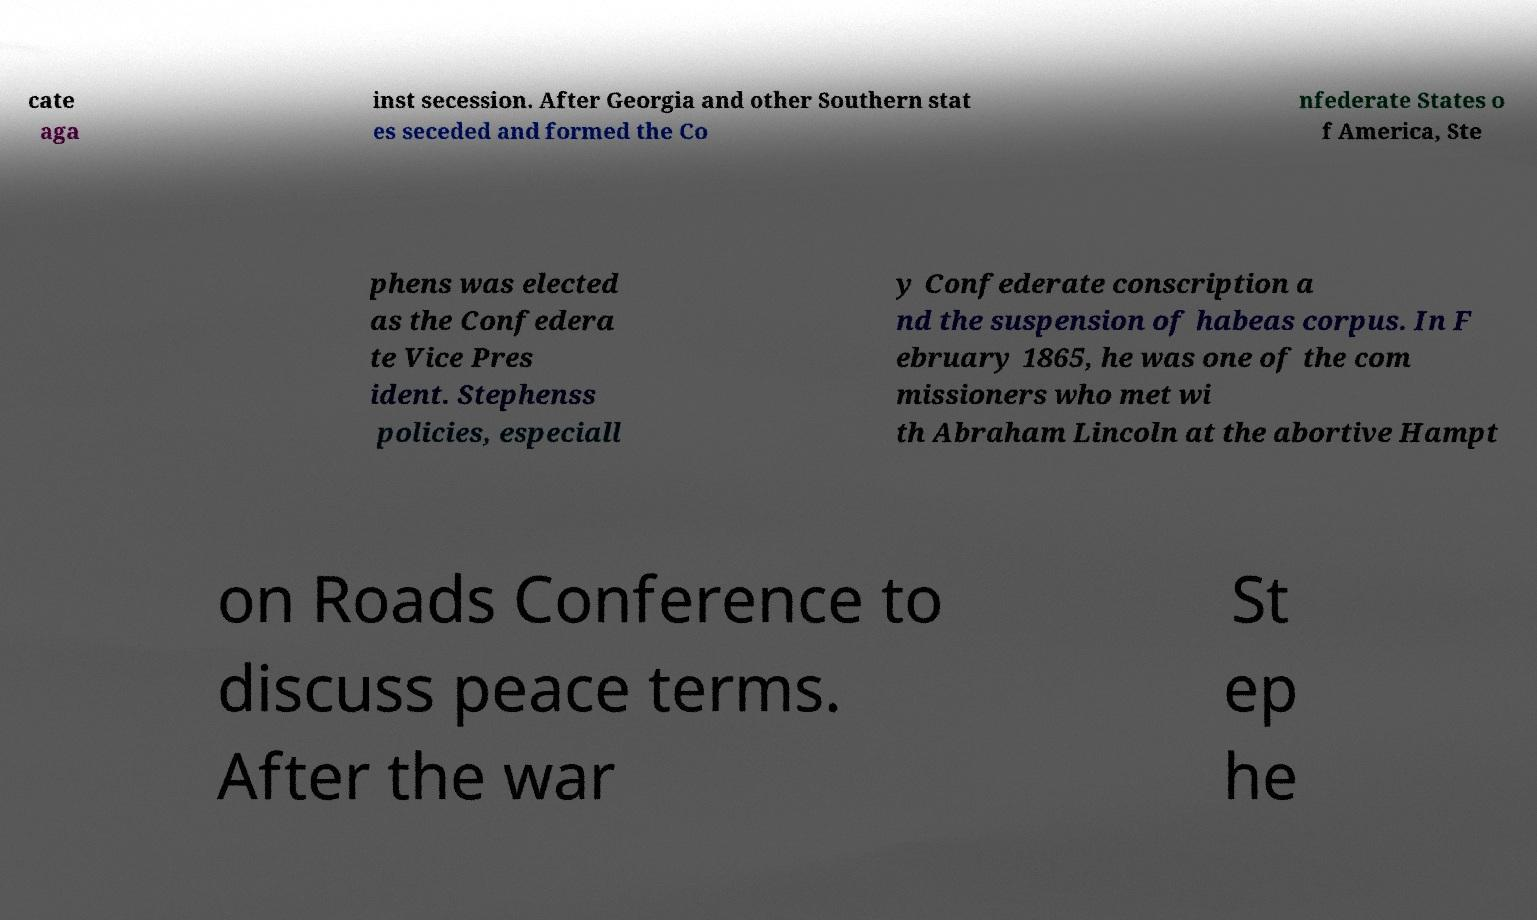Please read and relay the text visible in this image. What does it say? cate aga inst secession. After Georgia and other Southern stat es seceded and formed the Co nfederate States o f America, Ste phens was elected as the Confedera te Vice Pres ident. Stephenss policies, especiall y Confederate conscription a nd the suspension of habeas corpus. In F ebruary 1865, he was one of the com missioners who met wi th Abraham Lincoln at the abortive Hampt on Roads Conference to discuss peace terms. After the war St ep he 